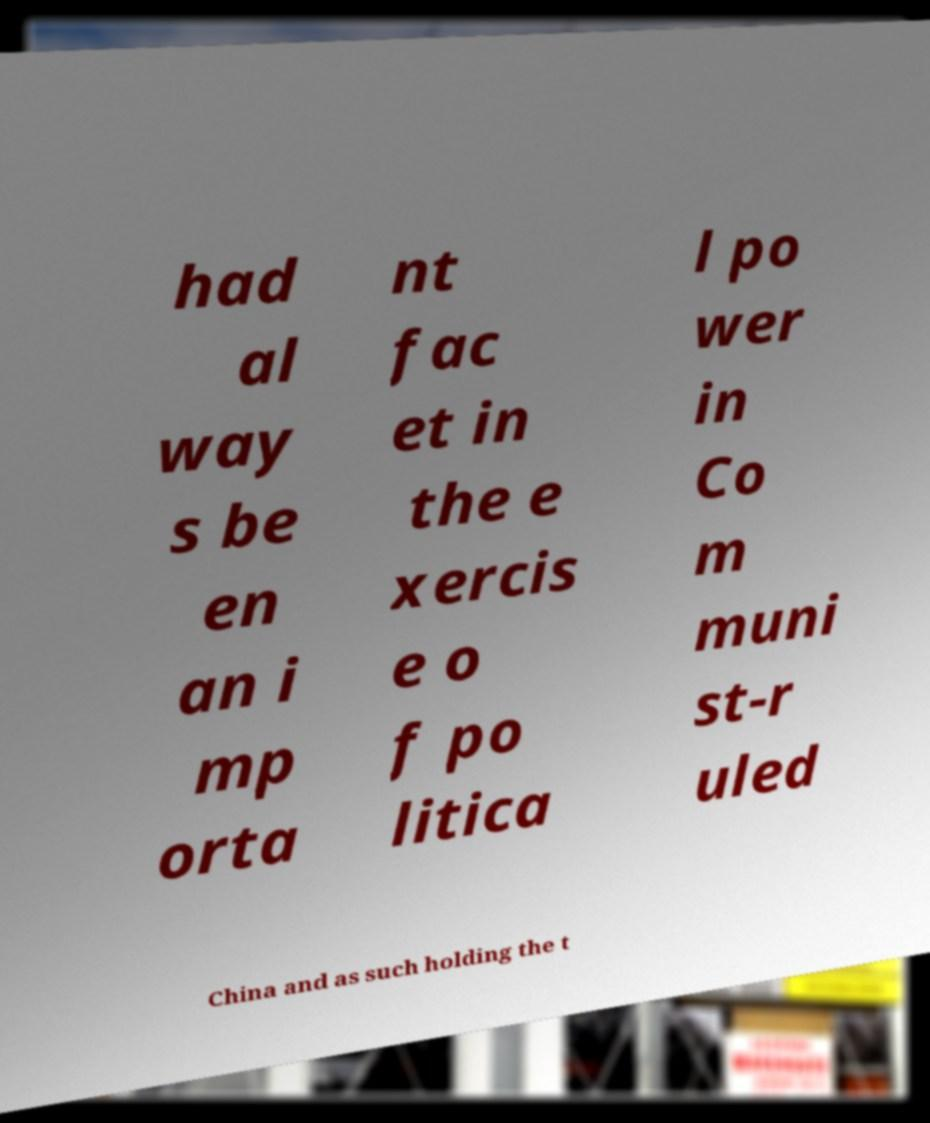Can you accurately transcribe the text from the provided image for me? had al way s be en an i mp orta nt fac et in the e xercis e o f po litica l po wer in Co m muni st-r uled China and as such holding the t 